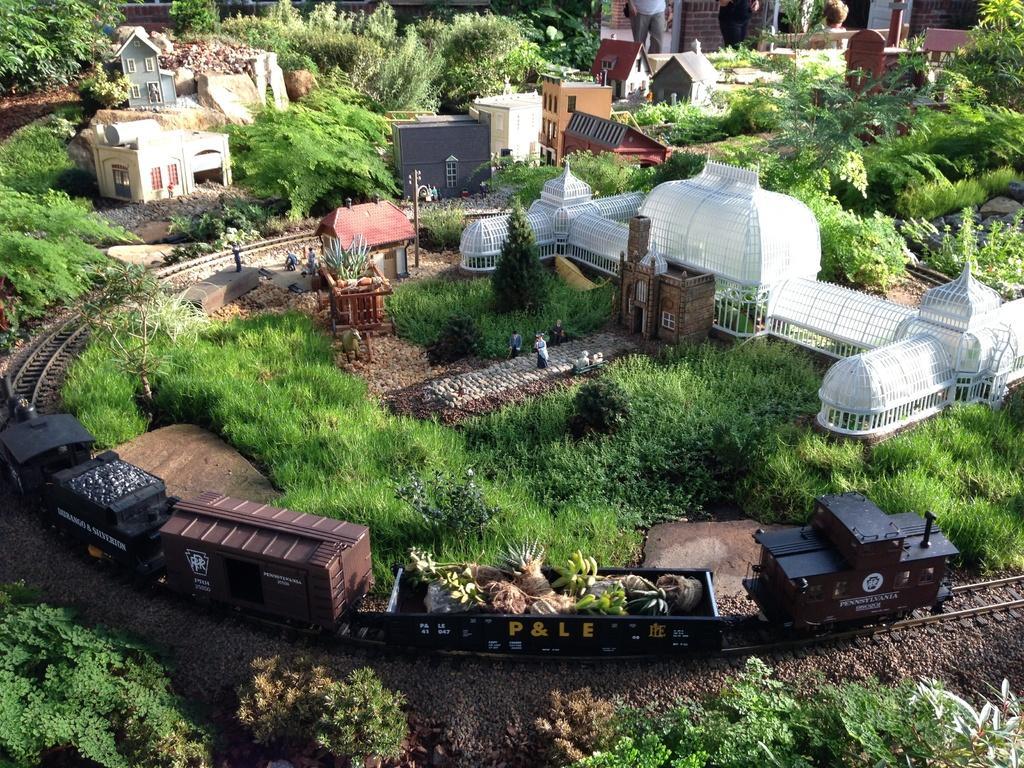How would you summarize this image in a sentence or two? In this picture we can see plants, pole, train on a railway track, some objects, buildings with windows and in the background we can see two people. 